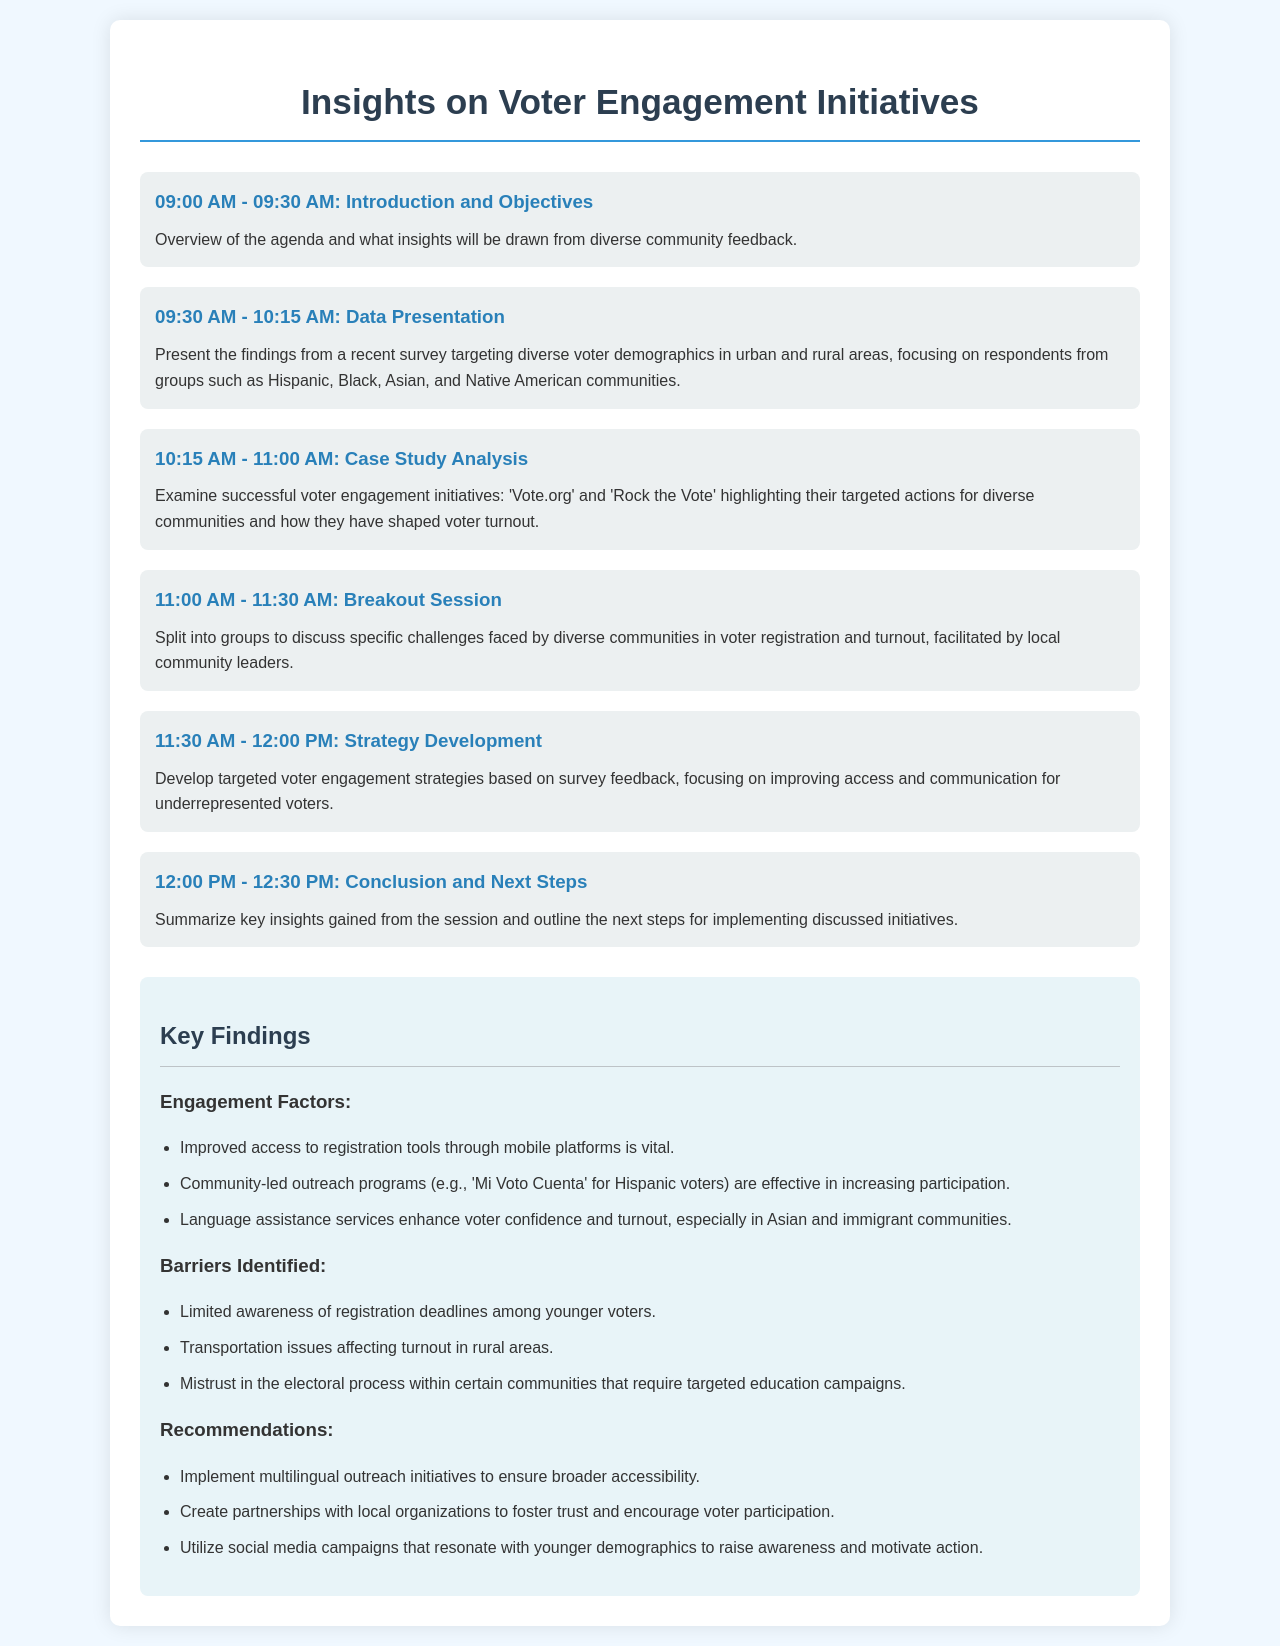What time does the introduction and objectives start? The schedule states that the introduction and objectives start at 09:00 AM.
Answer: 09:00 AM What are the targeted voter demographics in the data presentation? The data presentation focuses on Hispanic, Black, Asian, and Native American communities.
Answer: Hispanic, Black, Asian, and Native American communities What successful initiatives are examined during the case study analysis? The schedule mentions 'Vote.org' and 'Rock the Vote' as the initiatives being examined.
Answer: Vote.org and Rock the Vote How long is the breakout session? According to the schedule, the breakout session lasts for 30 minutes, from 11:00 AM to 11:30 AM.
Answer: 30 minutes What is one barrier identified affecting voter turnout? The document lists 'Transportation issues affecting turnout in rural areas' as a barrier.
Answer: Transportation issues What recommendation is made regarding outreach initiatives? The document recommends implementing multilingual outreach initiatives for broader accessibility.
Answer: Multilingual outreach initiatives Which community-led outreach program is mentioned for Hispanic voters? The outreach program mentioned for Hispanic voters is 'Mi Voto Cuenta'.
Answer: Mi Voto Cuenta What is the duration of the strategy development session? The strategy development session is scheduled for 30 minutes, from 11:30 AM to 12:00 PM.
Answer: 30 minutes What is the time slot for the conclusion and next steps? The conclusion and next steps are scheduled from 12:00 PM to 12:30 PM.
Answer: 12:00 PM - 12:30 PM 